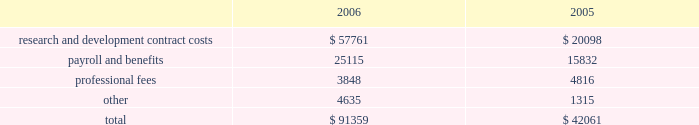Vertex pharmaceuticals incorporated notes to consolidated financial statements ( continued ) i .
Altus investment ( continued ) of the offering , held 450000 shares of redeemable preferred stock , which are not convertible into common stock and which are redeemable for $ 10.00 per share plus annual dividends of $ 0.50 per share , which have been accruing since the redeemable preferred stock was issued in 1999 , at vertex 2019s option on or after december 31 , 2010 , or by altus at any time .
The company was restricted from trading altus securities for a period of six months following the initial public offering .
When the altus securities trading restrictions expired , the company sold the 817749 shares of altus common stock for approximately $ 11.7 million , resulting in a realized gain of approximately $ 7.7 million in august 2006 .
Additionally when the restrictions expired , the company began accounting for the altus warrants as derivative instruments under the financial accounting standards board statement no .
Fas 133 , 201caccounting for derivative instruments and hedging activities 201d ( 201cfas 133 201d ) .
In accordance with fas 133 , in the third quarter of 2006 , the company recorded the altus warrants on its consolidated balance sheet at a fair market value of $ 19.1 million and recorded an unrealized gain on the fair market value of the altus warrants of $ 4.3 million .
In the fourth quarter of 2006 the company sold the altus warrants for approximately $ 18.3 million , resulting in a realized loss of $ 0.7 million .
As a result of the company 2019s sales of altus common stock and altus warrrants in 2006 , the company recorded a realized gain on a sale of investment of $ 11.2 million .
In accordance with the company 2019s policy , as outlined in note b , 201caccounting policies , 201d the company assessed its investment in altus , which it accounts for using the cost method , and determined that there had not been any adjustments to the fair values of that investment that would require the company to write down the investment basis of the asset , in 2005 and 2006 .
The company 2019s cost basis carrying value in its outstanding equity and warrants of altus was $ 18.9 million at december 31 , 2005 .
Accrued expenses and other current liabilities accrued expenses and other current liabilities consist of the following at december 31 ( in thousands ) : k .
Commitments the company leases its facilities and certain equipment under non-cancelable operating leases .
The company 2019s leases have terms through april 2018 .
The term of the kendall square lease began january 1 , 2003 and lease payments commenced in may 2003 .
The company had an obligation under the kendall square lease , staged through 2006 , to build-out the space into finished laboratory and office space .
This lease will expire in 2018 , and the company has the option to extend the term for two consecutive terms of ten years each , ultimately expiring in 2038 .
The company occupies and uses for its operations approximately 120000 square feet of the kendall square facility .
The company has sublease arrangements in place for the remaining rentable square footage of the kendall square facility , with initial terms that expires in april 2011 and august 2012 .
See note e , 201crestructuring 201d for further information. .
Research and development contract costs $ 57761 $ 20098 payroll and benefits 25115 15832 professional fees 3848 4816 4635 1315 $ 91359 $ 42061 .
What was the average price per share , in dollars , of the stock the company sold in august 2006? 
Computations: ((11.7 * 1000000) / 817749)
Answer: 14.30757. 